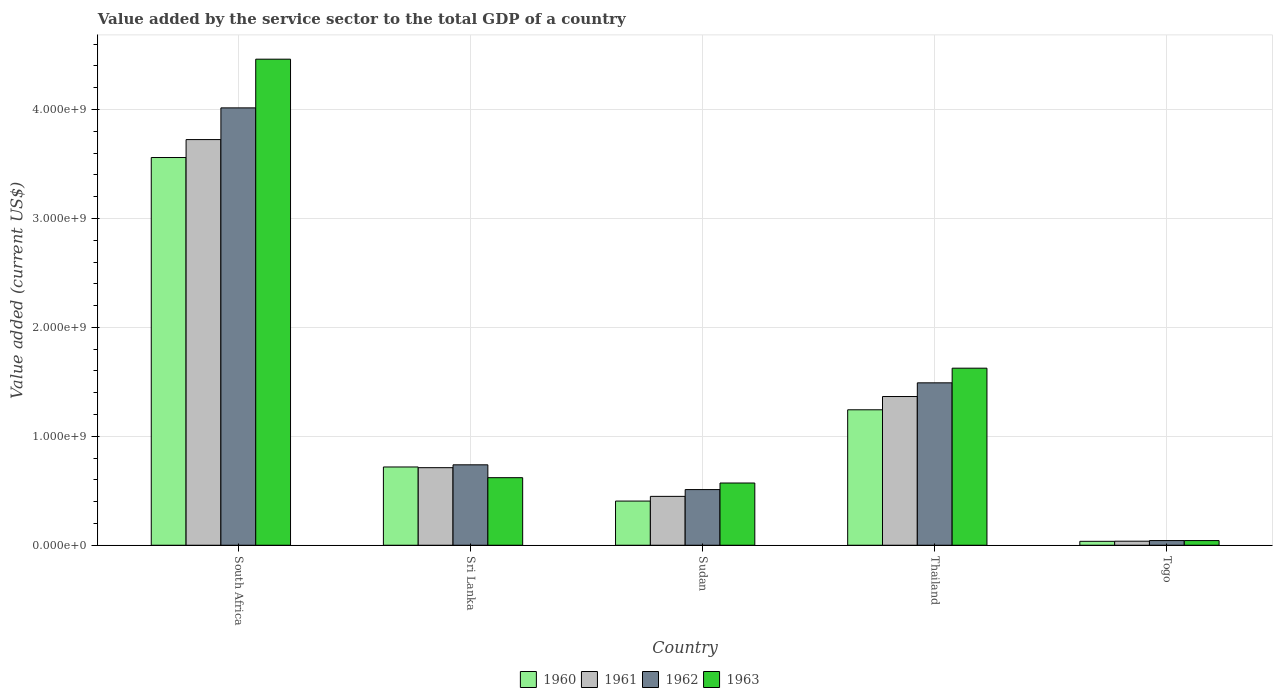How many groups of bars are there?
Ensure brevity in your answer.  5. Are the number of bars per tick equal to the number of legend labels?
Offer a very short reply. Yes. Are the number of bars on each tick of the X-axis equal?
Provide a succinct answer. Yes. How many bars are there on the 1st tick from the left?
Your answer should be compact. 4. What is the label of the 3rd group of bars from the left?
Offer a very short reply. Sudan. In how many cases, is the number of bars for a given country not equal to the number of legend labels?
Provide a succinct answer. 0. What is the value added by the service sector to the total GDP in 1961 in Sudan?
Keep it short and to the point. 4.49e+08. Across all countries, what is the maximum value added by the service sector to the total GDP in 1962?
Provide a short and direct response. 4.01e+09. Across all countries, what is the minimum value added by the service sector to the total GDP in 1962?
Your answer should be compact. 4.29e+07. In which country was the value added by the service sector to the total GDP in 1960 maximum?
Make the answer very short. South Africa. In which country was the value added by the service sector to the total GDP in 1961 minimum?
Offer a very short reply. Togo. What is the total value added by the service sector to the total GDP in 1960 in the graph?
Your answer should be compact. 5.96e+09. What is the difference between the value added by the service sector to the total GDP in 1960 in South Africa and that in Thailand?
Provide a short and direct response. 2.32e+09. What is the difference between the value added by the service sector to the total GDP in 1962 in South Africa and the value added by the service sector to the total GDP in 1963 in Thailand?
Your response must be concise. 2.39e+09. What is the average value added by the service sector to the total GDP in 1961 per country?
Make the answer very short. 1.26e+09. What is the difference between the value added by the service sector to the total GDP of/in 1961 and value added by the service sector to the total GDP of/in 1962 in South Africa?
Give a very brief answer. -2.91e+08. In how many countries, is the value added by the service sector to the total GDP in 1960 greater than 3200000000 US$?
Your response must be concise. 1. What is the ratio of the value added by the service sector to the total GDP in 1963 in Sri Lanka to that in Sudan?
Provide a succinct answer. 1.09. Is the value added by the service sector to the total GDP in 1961 in South Africa less than that in Sri Lanka?
Your response must be concise. No. Is the difference between the value added by the service sector to the total GDP in 1961 in South Africa and Togo greater than the difference between the value added by the service sector to the total GDP in 1962 in South Africa and Togo?
Keep it short and to the point. No. What is the difference between the highest and the second highest value added by the service sector to the total GDP in 1963?
Ensure brevity in your answer.  3.84e+09. What is the difference between the highest and the lowest value added by the service sector to the total GDP in 1961?
Ensure brevity in your answer.  3.69e+09. Is it the case that in every country, the sum of the value added by the service sector to the total GDP in 1960 and value added by the service sector to the total GDP in 1961 is greater than the sum of value added by the service sector to the total GDP in 1962 and value added by the service sector to the total GDP in 1963?
Make the answer very short. No. How many countries are there in the graph?
Your response must be concise. 5. Does the graph contain any zero values?
Your answer should be compact. No. What is the title of the graph?
Your answer should be compact. Value added by the service sector to the total GDP of a country. Does "1967" appear as one of the legend labels in the graph?
Offer a very short reply. No. What is the label or title of the Y-axis?
Offer a very short reply. Value added (current US$). What is the Value added (current US$) of 1960 in South Africa?
Your answer should be very brief. 3.56e+09. What is the Value added (current US$) in 1961 in South Africa?
Ensure brevity in your answer.  3.72e+09. What is the Value added (current US$) of 1962 in South Africa?
Offer a terse response. 4.01e+09. What is the Value added (current US$) in 1963 in South Africa?
Keep it short and to the point. 4.46e+09. What is the Value added (current US$) of 1960 in Sri Lanka?
Give a very brief answer. 7.18e+08. What is the Value added (current US$) in 1961 in Sri Lanka?
Keep it short and to the point. 7.12e+08. What is the Value added (current US$) of 1962 in Sri Lanka?
Keep it short and to the point. 7.38e+08. What is the Value added (current US$) of 1963 in Sri Lanka?
Give a very brief answer. 6.20e+08. What is the Value added (current US$) in 1960 in Sudan?
Ensure brevity in your answer.  4.06e+08. What is the Value added (current US$) in 1961 in Sudan?
Your response must be concise. 4.49e+08. What is the Value added (current US$) in 1962 in Sudan?
Ensure brevity in your answer.  5.11e+08. What is the Value added (current US$) in 1963 in Sudan?
Offer a terse response. 5.71e+08. What is the Value added (current US$) in 1960 in Thailand?
Offer a very short reply. 1.24e+09. What is the Value added (current US$) of 1961 in Thailand?
Your answer should be very brief. 1.37e+09. What is the Value added (current US$) of 1962 in Thailand?
Provide a succinct answer. 1.49e+09. What is the Value added (current US$) in 1963 in Thailand?
Your answer should be very brief. 1.63e+09. What is the Value added (current US$) of 1960 in Togo?
Make the answer very short. 3.59e+07. What is the Value added (current US$) of 1961 in Togo?
Your answer should be very brief. 3.71e+07. What is the Value added (current US$) of 1962 in Togo?
Keep it short and to the point. 4.29e+07. What is the Value added (current US$) in 1963 in Togo?
Keep it short and to the point. 4.29e+07. Across all countries, what is the maximum Value added (current US$) in 1960?
Your answer should be very brief. 3.56e+09. Across all countries, what is the maximum Value added (current US$) in 1961?
Provide a succinct answer. 3.72e+09. Across all countries, what is the maximum Value added (current US$) in 1962?
Keep it short and to the point. 4.01e+09. Across all countries, what is the maximum Value added (current US$) of 1963?
Ensure brevity in your answer.  4.46e+09. Across all countries, what is the minimum Value added (current US$) in 1960?
Offer a very short reply. 3.59e+07. Across all countries, what is the minimum Value added (current US$) of 1961?
Offer a very short reply. 3.71e+07. Across all countries, what is the minimum Value added (current US$) of 1962?
Give a very brief answer. 4.29e+07. Across all countries, what is the minimum Value added (current US$) of 1963?
Provide a succinct answer. 4.29e+07. What is the total Value added (current US$) in 1960 in the graph?
Keep it short and to the point. 5.96e+09. What is the total Value added (current US$) in 1961 in the graph?
Provide a short and direct response. 6.29e+09. What is the total Value added (current US$) in 1962 in the graph?
Make the answer very short. 6.80e+09. What is the total Value added (current US$) in 1963 in the graph?
Make the answer very short. 7.32e+09. What is the difference between the Value added (current US$) of 1960 in South Africa and that in Sri Lanka?
Offer a terse response. 2.84e+09. What is the difference between the Value added (current US$) in 1961 in South Africa and that in Sri Lanka?
Offer a very short reply. 3.01e+09. What is the difference between the Value added (current US$) in 1962 in South Africa and that in Sri Lanka?
Make the answer very short. 3.28e+09. What is the difference between the Value added (current US$) in 1963 in South Africa and that in Sri Lanka?
Your answer should be compact. 3.84e+09. What is the difference between the Value added (current US$) of 1960 in South Africa and that in Sudan?
Keep it short and to the point. 3.15e+09. What is the difference between the Value added (current US$) in 1961 in South Africa and that in Sudan?
Your answer should be compact. 3.28e+09. What is the difference between the Value added (current US$) of 1962 in South Africa and that in Sudan?
Make the answer very short. 3.50e+09. What is the difference between the Value added (current US$) of 1963 in South Africa and that in Sudan?
Your response must be concise. 3.89e+09. What is the difference between the Value added (current US$) in 1960 in South Africa and that in Thailand?
Your answer should be very brief. 2.32e+09. What is the difference between the Value added (current US$) of 1961 in South Africa and that in Thailand?
Your answer should be compact. 2.36e+09. What is the difference between the Value added (current US$) of 1962 in South Africa and that in Thailand?
Your answer should be compact. 2.52e+09. What is the difference between the Value added (current US$) in 1963 in South Africa and that in Thailand?
Your response must be concise. 2.84e+09. What is the difference between the Value added (current US$) in 1960 in South Africa and that in Togo?
Your answer should be compact. 3.52e+09. What is the difference between the Value added (current US$) in 1961 in South Africa and that in Togo?
Ensure brevity in your answer.  3.69e+09. What is the difference between the Value added (current US$) of 1962 in South Africa and that in Togo?
Provide a succinct answer. 3.97e+09. What is the difference between the Value added (current US$) in 1963 in South Africa and that in Togo?
Your answer should be very brief. 4.42e+09. What is the difference between the Value added (current US$) in 1960 in Sri Lanka and that in Sudan?
Your answer should be very brief. 3.13e+08. What is the difference between the Value added (current US$) of 1961 in Sri Lanka and that in Sudan?
Make the answer very short. 2.63e+08. What is the difference between the Value added (current US$) in 1962 in Sri Lanka and that in Sudan?
Provide a succinct answer. 2.27e+08. What is the difference between the Value added (current US$) of 1963 in Sri Lanka and that in Sudan?
Provide a short and direct response. 4.89e+07. What is the difference between the Value added (current US$) in 1960 in Sri Lanka and that in Thailand?
Provide a short and direct response. -5.25e+08. What is the difference between the Value added (current US$) in 1961 in Sri Lanka and that in Thailand?
Give a very brief answer. -6.53e+08. What is the difference between the Value added (current US$) of 1962 in Sri Lanka and that in Thailand?
Make the answer very short. -7.53e+08. What is the difference between the Value added (current US$) in 1963 in Sri Lanka and that in Thailand?
Offer a very short reply. -1.01e+09. What is the difference between the Value added (current US$) in 1960 in Sri Lanka and that in Togo?
Offer a terse response. 6.83e+08. What is the difference between the Value added (current US$) in 1961 in Sri Lanka and that in Togo?
Offer a very short reply. 6.75e+08. What is the difference between the Value added (current US$) in 1962 in Sri Lanka and that in Togo?
Offer a very short reply. 6.95e+08. What is the difference between the Value added (current US$) of 1963 in Sri Lanka and that in Togo?
Your answer should be very brief. 5.77e+08. What is the difference between the Value added (current US$) of 1960 in Sudan and that in Thailand?
Offer a terse response. -8.38e+08. What is the difference between the Value added (current US$) in 1961 in Sudan and that in Thailand?
Ensure brevity in your answer.  -9.17e+08. What is the difference between the Value added (current US$) in 1962 in Sudan and that in Thailand?
Your response must be concise. -9.80e+08. What is the difference between the Value added (current US$) of 1963 in Sudan and that in Thailand?
Your response must be concise. -1.05e+09. What is the difference between the Value added (current US$) in 1960 in Sudan and that in Togo?
Offer a very short reply. 3.70e+08. What is the difference between the Value added (current US$) of 1961 in Sudan and that in Togo?
Give a very brief answer. 4.11e+08. What is the difference between the Value added (current US$) in 1962 in Sudan and that in Togo?
Your answer should be very brief. 4.68e+08. What is the difference between the Value added (current US$) in 1963 in Sudan and that in Togo?
Offer a terse response. 5.28e+08. What is the difference between the Value added (current US$) of 1960 in Thailand and that in Togo?
Ensure brevity in your answer.  1.21e+09. What is the difference between the Value added (current US$) in 1961 in Thailand and that in Togo?
Provide a succinct answer. 1.33e+09. What is the difference between the Value added (current US$) of 1962 in Thailand and that in Togo?
Offer a terse response. 1.45e+09. What is the difference between the Value added (current US$) in 1963 in Thailand and that in Togo?
Provide a succinct answer. 1.58e+09. What is the difference between the Value added (current US$) in 1960 in South Africa and the Value added (current US$) in 1961 in Sri Lanka?
Provide a short and direct response. 2.85e+09. What is the difference between the Value added (current US$) in 1960 in South Africa and the Value added (current US$) in 1962 in Sri Lanka?
Your response must be concise. 2.82e+09. What is the difference between the Value added (current US$) of 1960 in South Africa and the Value added (current US$) of 1963 in Sri Lanka?
Provide a succinct answer. 2.94e+09. What is the difference between the Value added (current US$) in 1961 in South Africa and the Value added (current US$) in 1962 in Sri Lanka?
Keep it short and to the point. 2.99e+09. What is the difference between the Value added (current US$) of 1961 in South Africa and the Value added (current US$) of 1963 in Sri Lanka?
Keep it short and to the point. 3.10e+09. What is the difference between the Value added (current US$) in 1962 in South Africa and the Value added (current US$) in 1963 in Sri Lanka?
Your answer should be very brief. 3.39e+09. What is the difference between the Value added (current US$) of 1960 in South Africa and the Value added (current US$) of 1961 in Sudan?
Your answer should be compact. 3.11e+09. What is the difference between the Value added (current US$) in 1960 in South Africa and the Value added (current US$) in 1962 in Sudan?
Offer a terse response. 3.05e+09. What is the difference between the Value added (current US$) in 1960 in South Africa and the Value added (current US$) in 1963 in Sudan?
Your answer should be compact. 2.99e+09. What is the difference between the Value added (current US$) of 1961 in South Africa and the Value added (current US$) of 1962 in Sudan?
Your answer should be compact. 3.21e+09. What is the difference between the Value added (current US$) of 1961 in South Africa and the Value added (current US$) of 1963 in Sudan?
Provide a short and direct response. 3.15e+09. What is the difference between the Value added (current US$) of 1962 in South Africa and the Value added (current US$) of 1963 in Sudan?
Provide a short and direct response. 3.44e+09. What is the difference between the Value added (current US$) in 1960 in South Africa and the Value added (current US$) in 1961 in Thailand?
Offer a terse response. 2.19e+09. What is the difference between the Value added (current US$) of 1960 in South Africa and the Value added (current US$) of 1962 in Thailand?
Your response must be concise. 2.07e+09. What is the difference between the Value added (current US$) of 1960 in South Africa and the Value added (current US$) of 1963 in Thailand?
Keep it short and to the point. 1.93e+09. What is the difference between the Value added (current US$) of 1961 in South Africa and the Value added (current US$) of 1962 in Thailand?
Give a very brief answer. 2.23e+09. What is the difference between the Value added (current US$) in 1961 in South Africa and the Value added (current US$) in 1963 in Thailand?
Ensure brevity in your answer.  2.10e+09. What is the difference between the Value added (current US$) of 1962 in South Africa and the Value added (current US$) of 1963 in Thailand?
Offer a very short reply. 2.39e+09. What is the difference between the Value added (current US$) of 1960 in South Africa and the Value added (current US$) of 1961 in Togo?
Provide a short and direct response. 3.52e+09. What is the difference between the Value added (current US$) of 1960 in South Africa and the Value added (current US$) of 1962 in Togo?
Give a very brief answer. 3.52e+09. What is the difference between the Value added (current US$) of 1960 in South Africa and the Value added (current US$) of 1963 in Togo?
Ensure brevity in your answer.  3.52e+09. What is the difference between the Value added (current US$) of 1961 in South Africa and the Value added (current US$) of 1962 in Togo?
Offer a very short reply. 3.68e+09. What is the difference between the Value added (current US$) of 1961 in South Africa and the Value added (current US$) of 1963 in Togo?
Your answer should be very brief. 3.68e+09. What is the difference between the Value added (current US$) of 1962 in South Africa and the Value added (current US$) of 1963 in Togo?
Your answer should be very brief. 3.97e+09. What is the difference between the Value added (current US$) in 1960 in Sri Lanka and the Value added (current US$) in 1961 in Sudan?
Offer a very short reply. 2.70e+08. What is the difference between the Value added (current US$) in 1960 in Sri Lanka and the Value added (current US$) in 1962 in Sudan?
Ensure brevity in your answer.  2.08e+08. What is the difference between the Value added (current US$) of 1960 in Sri Lanka and the Value added (current US$) of 1963 in Sudan?
Provide a short and direct response. 1.47e+08. What is the difference between the Value added (current US$) in 1961 in Sri Lanka and the Value added (current US$) in 1962 in Sudan?
Your response must be concise. 2.01e+08. What is the difference between the Value added (current US$) in 1961 in Sri Lanka and the Value added (current US$) in 1963 in Sudan?
Offer a terse response. 1.41e+08. What is the difference between the Value added (current US$) in 1962 in Sri Lanka and the Value added (current US$) in 1963 in Sudan?
Offer a terse response. 1.67e+08. What is the difference between the Value added (current US$) of 1960 in Sri Lanka and the Value added (current US$) of 1961 in Thailand?
Ensure brevity in your answer.  -6.47e+08. What is the difference between the Value added (current US$) of 1960 in Sri Lanka and the Value added (current US$) of 1962 in Thailand?
Give a very brief answer. -7.72e+08. What is the difference between the Value added (current US$) in 1960 in Sri Lanka and the Value added (current US$) in 1963 in Thailand?
Your response must be concise. -9.07e+08. What is the difference between the Value added (current US$) of 1961 in Sri Lanka and the Value added (current US$) of 1962 in Thailand?
Your answer should be compact. -7.79e+08. What is the difference between the Value added (current US$) in 1961 in Sri Lanka and the Value added (current US$) in 1963 in Thailand?
Provide a short and direct response. -9.13e+08. What is the difference between the Value added (current US$) of 1962 in Sri Lanka and the Value added (current US$) of 1963 in Thailand?
Provide a succinct answer. -8.87e+08. What is the difference between the Value added (current US$) in 1960 in Sri Lanka and the Value added (current US$) in 1961 in Togo?
Offer a terse response. 6.81e+08. What is the difference between the Value added (current US$) in 1960 in Sri Lanka and the Value added (current US$) in 1962 in Togo?
Offer a terse response. 6.76e+08. What is the difference between the Value added (current US$) in 1960 in Sri Lanka and the Value added (current US$) in 1963 in Togo?
Offer a very short reply. 6.76e+08. What is the difference between the Value added (current US$) in 1961 in Sri Lanka and the Value added (current US$) in 1962 in Togo?
Your answer should be very brief. 6.69e+08. What is the difference between the Value added (current US$) of 1961 in Sri Lanka and the Value added (current US$) of 1963 in Togo?
Provide a succinct answer. 6.69e+08. What is the difference between the Value added (current US$) in 1962 in Sri Lanka and the Value added (current US$) in 1963 in Togo?
Your answer should be very brief. 6.95e+08. What is the difference between the Value added (current US$) in 1960 in Sudan and the Value added (current US$) in 1961 in Thailand?
Give a very brief answer. -9.60e+08. What is the difference between the Value added (current US$) of 1960 in Sudan and the Value added (current US$) of 1962 in Thailand?
Give a very brief answer. -1.09e+09. What is the difference between the Value added (current US$) of 1960 in Sudan and the Value added (current US$) of 1963 in Thailand?
Offer a terse response. -1.22e+09. What is the difference between the Value added (current US$) in 1961 in Sudan and the Value added (current US$) in 1962 in Thailand?
Give a very brief answer. -1.04e+09. What is the difference between the Value added (current US$) of 1961 in Sudan and the Value added (current US$) of 1963 in Thailand?
Make the answer very short. -1.18e+09. What is the difference between the Value added (current US$) of 1962 in Sudan and the Value added (current US$) of 1963 in Thailand?
Give a very brief answer. -1.11e+09. What is the difference between the Value added (current US$) of 1960 in Sudan and the Value added (current US$) of 1961 in Togo?
Ensure brevity in your answer.  3.68e+08. What is the difference between the Value added (current US$) of 1960 in Sudan and the Value added (current US$) of 1962 in Togo?
Provide a succinct answer. 3.63e+08. What is the difference between the Value added (current US$) in 1960 in Sudan and the Value added (current US$) in 1963 in Togo?
Keep it short and to the point. 3.63e+08. What is the difference between the Value added (current US$) of 1961 in Sudan and the Value added (current US$) of 1962 in Togo?
Ensure brevity in your answer.  4.06e+08. What is the difference between the Value added (current US$) in 1961 in Sudan and the Value added (current US$) in 1963 in Togo?
Provide a short and direct response. 4.06e+08. What is the difference between the Value added (current US$) of 1962 in Sudan and the Value added (current US$) of 1963 in Togo?
Ensure brevity in your answer.  4.68e+08. What is the difference between the Value added (current US$) in 1960 in Thailand and the Value added (current US$) in 1961 in Togo?
Keep it short and to the point. 1.21e+09. What is the difference between the Value added (current US$) of 1960 in Thailand and the Value added (current US$) of 1962 in Togo?
Provide a succinct answer. 1.20e+09. What is the difference between the Value added (current US$) of 1960 in Thailand and the Value added (current US$) of 1963 in Togo?
Your response must be concise. 1.20e+09. What is the difference between the Value added (current US$) in 1961 in Thailand and the Value added (current US$) in 1962 in Togo?
Offer a very short reply. 1.32e+09. What is the difference between the Value added (current US$) of 1961 in Thailand and the Value added (current US$) of 1963 in Togo?
Offer a terse response. 1.32e+09. What is the difference between the Value added (current US$) of 1962 in Thailand and the Value added (current US$) of 1963 in Togo?
Ensure brevity in your answer.  1.45e+09. What is the average Value added (current US$) in 1960 per country?
Give a very brief answer. 1.19e+09. What is the average Value added (current US$) in 1961 per country?
Keep it short and to the point. 1.26e+09. What is the average Value added (current US$) in 1962 per country?
Offer a terse response. 1.36e+09. What is the average Value added (current US$) in 1963 per country?
Ensure brevity in your answer.  1.46e+09. What is the difference between the Value added (current US$) in 1960 and Value added (current US$) in 1961 in South Africa?
Give a very brief answer. -1.65e+08. What is the difference between the Value added (current US$) of 1960 and Value added (current US$) of 1962 in South Africa?
Your response must be concise. -4.56e+08. What is the difference between the Value added (current US$) of 1960 and Value added (current US$) of 1963 in South Africa?
Provide a succinct answer. -9.03e+08. What is the difference between the Value added (current US$) in 1961 and Value added (current US$) in 1962 in South Africa?
Make the answer very short. -2.91e+08. What is the difference between the Value added (current US$) in 1961 and Value added (current US$) in 1963 in South Africa?
Your answer should be very brief. -7.38e+08. What is the difference between the Value added (current US$) in 1962 and Value added (current US$) in 1963 in South Africa?
Your answer should be very brief. -4.47e+08. What is the difference between the Value added (current US$) of 1960 and Value added (current US$) of 1961 in Sri Lanka?
Provide a short and direct response. 6.51e+06. What is the difference between the Value added (current US$) of 1960 and Value added (current US$) of 1962 in Sri Lanka?
Offer a terse response. -1.98e+07. What is the difference between the Value added (current US$) of 1960 and Value added (current US$) of 1963 in Sri Lanka?
Provide a succinct answer. 9.83e+07. What is the difference between the Value added (current US$) in 1961 and Value added (current US$) in 1962 in Sri Lanka?
Make the answer very short. -2.63e+07. What is the difference between the Value added (current US$) in 1961 and Value added (current US$) in 1963 in Sri Lanka?
Ensure brevity in your answer.  9.18e+07. What is the difference between the Value added (current US$) of 1962 and Value added (current US$) of 1963 in Sri Lanka?
Keep it short and to the point. 1.18e+08. What is the difference between the Value added (current US$) in 1960 and Value added (current US$) in 1961 in Sudan?
Provide a short and direct response. -4.31e+07. What is the difference between the Value added (current US$) in 1960 and Value added (current US$) in 1962 in Sudan?
Your response must be concise. -1.05e+08. What is the difference between the Value added (current US$) of 1960 and Value added (current US$) of 1963 in Sudan?
Offer a very short reply. -1.66e+08. What is the difference between the Value added (current US$) of 1961 and Value added (current US$) of 1962 in Sudan?
Ensure brevity in your answer.  -6.23e+07. What is the difference between the Value added (current US$) of 1961 and Value added (current US$) of 1963 in Sudan?
Give a very brief answer. -1.23e+08. What is the difference between the Value added (current US$) in 1962 and Value added (current US$) in 1963 in Sudan?
Offer a terse response. -6.03e+07. What is the difference between the Value added (current US$) of 1960 and Value added (current US$) of 1961 in Thailand?
Keep it short and to the point. -1.22e+08. What is the difference between the Value added (current US$) in 1960 and Value added (current US$) in 1962 in Thailand?
Offer a very short reply. -2.47e+08. What is the difference between the Value added (current US$) of 1960 and Value added (current US$) of 1963 in Thailand?
Give a very brief answer. -3.82e+08. What is the difference between the Value added (current US$) of 1961 and Value added (current US$) of 1962 in Thailand?
Make the answer very short. -1.26e+08. What is the difference between the Value added (current US$) in 1961 and Value added (current US$) in 1963 in Thailand?
Make the answer very short. -2.60e+08. What is the difference between the Value added (current US$) in 1962 and Value added (current US$) in 1963 in Thailand?
Your response must be concise. -1.35e+08. What is the difference between the Value added (current US$) in 1960 and Value added (current US$) in 1961 in Togo?
Provide a succinct answer. -1.21e+06. What is the difference between the Value added (current US$) of 1960 and Value added (current US$) of 1962 in Togo?
Offer a terse response. -6.96e+06. What is the difference between the Value added (current US$) of 1960 and Value added (current US$) of 1963 in Togo?
Your response must be concise. -6.96e+06. What is the difference between the Value added (current US$) in 1961 and Value added (current US$) in 1962 in Togo?
Make the answer very short. -5.75e+06. What is the difference between the Value added (current US$) of 1961 and Value added (current US$) of 1963 in Togo?
Provide a short and direct response. -5.75e+06. What is the difference between the Value added (current US$) in 1962 and Value added (current US$) in 1963 in Togo?
Provide a short and direct response. 370.33. What is the ratio of the Value added (current US$) of 1960 in South Africa to that in Sri Lanka?
Provide a succinct answer. 4.95. What is the ratio of the Value added (current US$) of 1961 in South Africa to that in Sri Lanka?
Ensure brevity in your answer.  5.23. What is the ratio of the Value added (current US$) of 1962 in South Africa to that in Sri Lanka?
Make the answer very short. 5.44. What is the ratio of the Value added (current US$) in 1963 in South Africa to that in Sri Lanka?
Offer a terse response. 7.19. What is the ratio of the Value added (current US$) of 1960 in South Africa to that in Sudan?
Make the answer very short. 8.78. What is the ratio of the Value added (current US$) in 1961 in South Africa to that in Sudan?
Offer a very short reply. 8.3. What is the ratio of the Value added (current US$) in 1962 in South Africa to that in Sudan?
Offer a terse response. 7.86. What is the ratio of the Value added (current US$) in 1963 in South Africa to that in Sudan?
Ensure brevity in your answer.  7.81. What is the ratio of the Value added (current US$) in 1960 in South Africa to that in Thailand?
Offer a terse response. 2.86. What is the ratio of the Value added (current US$) of 1961 in South Africa to that in Thailand?
Provide a short and direct response. 2.73. What is the ratio of the Value added (current US$) of 1962 in South Africa to that in Thailand?
Your response must be concise. 2.69. What is the ratio of the Value added (current US$) in 1963 in South Africa to that in Thailand?
Give a very brief answer. 2.75. What is the ratio of the Value added (current US$) of 1960 in South Africa to that in Togo?
Your response must be concise. 99.17. What is the ratio of the Value added (current US$) in 1961 in South Africa to that in Togo?
Your response must be concise. 100.36. What is the ratio of the Value added (current US$) in 1962 in South Africa to that in Togo?
Give a very brief answer. 93.69. What is the ratio of the Value added (current US$) of 1963 in South Africa to that in Togo?
Your answer should be very brief. 104.12. What is the ratio of the Value added (current US$) in 1960 in Sri Lanka to that in Sudan?
Your answer should be compact. 1.77. What is the ratio of the Value added (current US$) of 1961 in Sri Lanka to that in Sudan?
Offer a terse response. 1.59. What is the ratio of the Value added (current US$) of 1962 in Sri Lanka to that in Sudan?
Offer a very short reply. 1.45. What is the ratio of the Value added (current US$) in 1963 in Sri Lanka to that in Sudan?
Ensure brevity in your answer.  1.09. What is the ratio of the Value added (current US$) in 1960 in Sri Lanka to that in Thailand?
Provide a short and direct response. 0.58. What is the ratio of the Value added (current US$) in 1961 in Sri Lanka to that in Thailand?
Offer a terse response. 0.52. What is the ratio of the Value added (current US$) in 1962 in Sri Lanka to that in Thailand?
Keep it short and to the point. 0.5. What is the ratio of the Value added (current US$) of 1963 in Sri Lanka to that in Thailand?
Provide a short and direct response. 0.38. What is the ratio of the Value added (current US$) in 1960 in Sri Lanka to that in Togo?
Keep it short and to the point. 20.02. What is the ratio of the Value added (current US$) of 1961 in Sri Lanka to that in Togo?
Keep it short and to the point. 19.19. What is the ratio of the Value added (current US$) of 1962 in Sri Lanka to that in Togo?
Provide a succinct answer. 17.23. What is the ratio of the Value added (current US$) in 1963 in Sri Lanka to that in Togo?
Offer a very short reply. 14.47. What is the ratio of the Value added (current US$) in 1960 in Sudan to that in Thailand?
Your answer should be very brief. 0.33. What is the ratio of the Value added (current US$) in 1961 in Sudan to that in Thailand?
Your response must be concise. 0.33. What is the ratio of the Value added (current US$) in 1962 in Sudan to that in Thailand?
Make the answer very short. 0.34. What is the ratio of the Value added (current US$) in 1963 in Sudan to that in Thailand?
Give a very brief answer. 0.35. What is the ratio of the Value added (current US$) in 1960 in Sudan to that in Togo?
Keep it short and to the point. 11.3. What is the ratio of the Value added (current US$) of 1961 in Sudan to that in Togo?
Provide a short and direct response. 12.09. What is the ratio of the Value added (current US$) of 1962 in Sudan to that in Togo?
Ensure brevity in your answer.  11.92. What is the ratio of the Value added (current US$) in 1963 in Sudan to that in Togo?
Give a very brief answer. 13.33. What is the ratio of the Value added (current US$) in 1960 in Thailand to that in Togo?
Keep it short and to the point. 34.65. What is the ratio of the Value added (current US$) in 1961 in Thailand to that in Togo?
Provide a short and direct response. 36.8. What is the ratio of the Value added (current US$) in 1962 in Thailand to that in Togo?
Provide a succinct answer. 34.79. What is the ratio of the Value added (current US$) of 1963 in Thailand to that in Togo?
Your answer should be very brief. 37.93. What is the difference between the highest and the second highest Value added (current US$) of 1960?
Keep it short and to the point. 2.32e+09. What is the difference between the highest and the second highest Value added (current US$) in 1961?
Your response must be concise. 2.36e+09. What is the difference between the highest and the second highest Value added (current US$) in 1962?
Offer a very short reply. 2.52e+09. What is the difference between the highest and the second highest Value added (current US$) in 1963?
Your response must be concise. 2.84e+09. What is the difference between the highest and the lowest Value added (current US$) in 1960?
Make the answer very short. 3.52e+09. What is the difference between the highest and the lowest Value added (current US$) in 1961?
Your answer should be compact. 3.69e+09. What is the difference between the highest and the lowest Value added (current US$) in 1962?
Make the answer very short. 3.97e+09. What is the difference between the highest and the lowest Value added (current US$) in 1963?
Provide a succinct answer. 4.42e+09. 